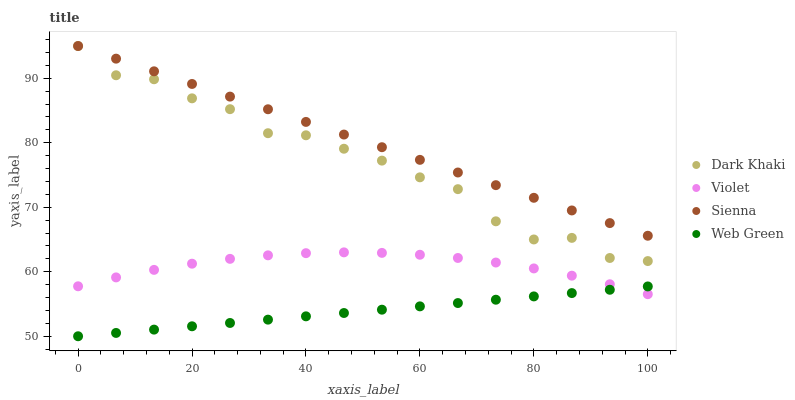Does Web Green have the minimum area under the curve?
Answer yes or no. Yes. Does Sienna have the maximum area under the curve?
Answer yes or no. Yes. Does Sienna have the minimum area under the curve?
Answer yes or no. No. Does Web Green have the maximum area under the curve?
Answer yes or no. No. Is Web Green the smoothest?
Answer yes or no. Yes. Is Dark Khaki the roughest?
Answer yes or no. Yes. Is Sienna the smoothest?
Answer yes or no. No. Is Sienna the roughest?
Answer yes or no. No. Does Web Green have the lowest value?
Answer yes or no. Yes. Does Sienna have the lowest value?
Answer yes or no. No. Does Sienna have the highest value?
Answer yes or no. Yes. Does Web Green have the highest value?
Answer yes or no. No. Is Web Green less than Dark Khaki?
Answer yes or no. Yes. Is Dark Khaki greater than Violet?
Answer yes or no. Yes. Does Sienna intersect Dark Khaki?
Answer yes or no. Yes. Is Sienna less than Dark Khaki?
Answer yes or no. No. Is Sienna greater than Dark Khaki?
Answer yes or no. No. Does Web Green intersect Dark Khaki?
Answer yes or no. No. 